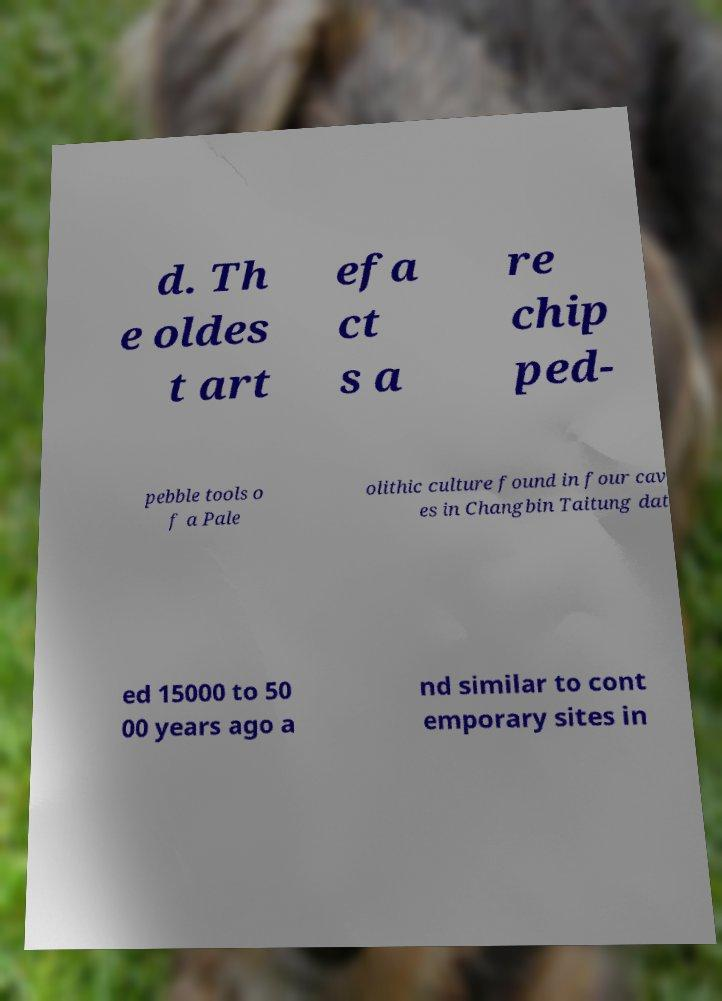There's text embedded in this image that I need extracted. Can you transcribe it verbatim? d. Th e oldes t art efa ct s a re chip ped- pebble tools o f a Pale olithic culture found in four cav es in Changbin Taitung dat ed 15000 to 50 00 years ago a nd similar to cont emporary sites in 